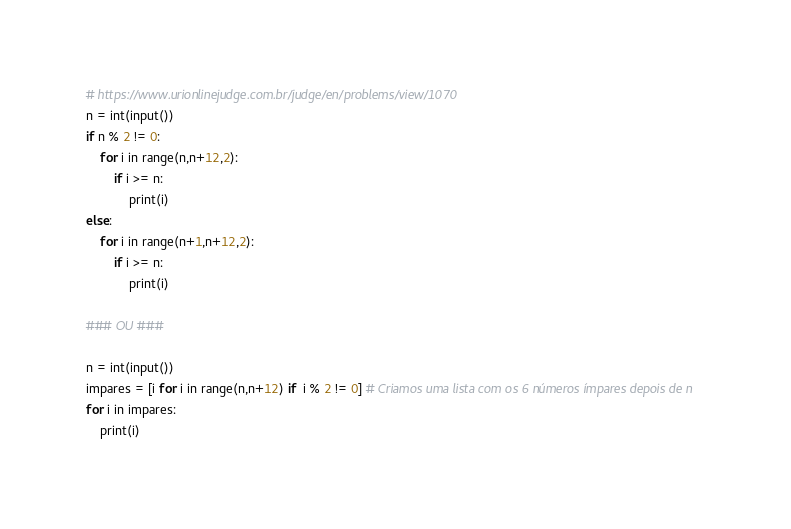Convert code to text. <code><loc_0><loc_0><loc_500><loc_500><_Python_># https://www.urionlinejudge.com.br/judge/en/problems/view/1070
n = int(input())
if n % 2 != 0:
    for i in range(n,n+12,2):
        if i >= n:
            print(i)
else:
    for i in range(n+1,n+12,2):
        if i >= n:
            print(i)

### OU ###

n = int(input())
impares = [i for i in range(n,n+12) if  i % 2 != 0] # Criamos uma lista com os 6 números ímpares depois de n
for i in impares:
    print(i)</code> 